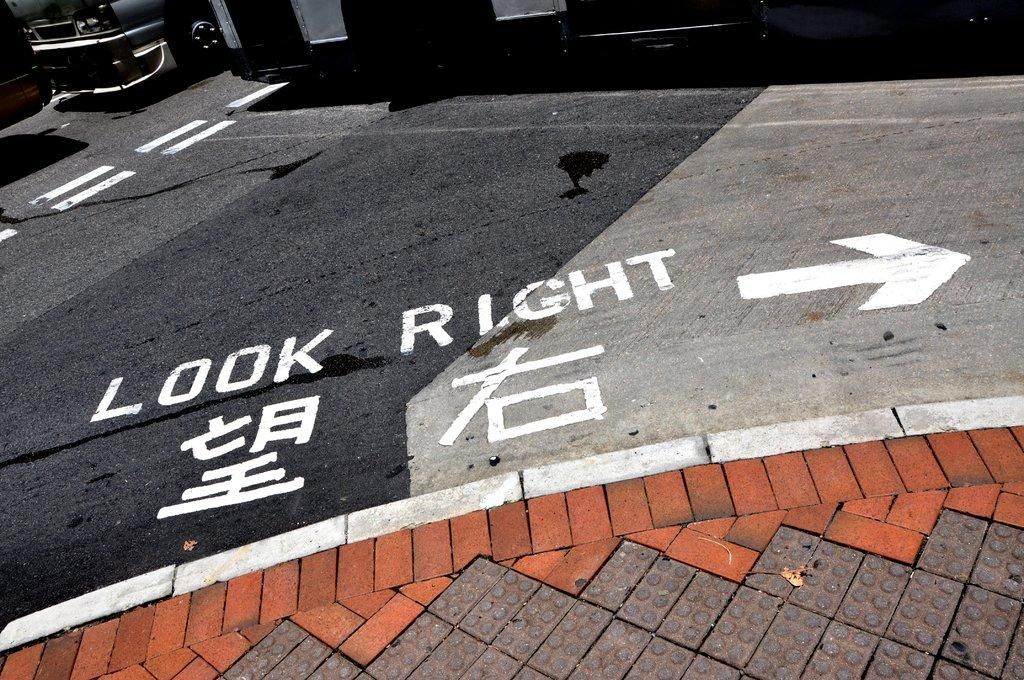What is the main subject in the image? There is a vehicle in the image. What else can be seen in the image besides the vehicle? There is a building in the image. Can you describe the lighting conditions in the image? The image is dark. What type of cream is being used to paint the building in the image? There is no cream or painting activity present in the image; it only features a vehicle and a building. 